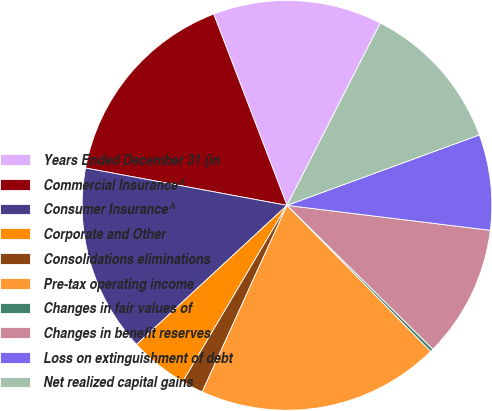Convert chart. <chart><loc_0><loc_0><loc_500><loc_500><pie_chart><fcel>Years Ended December 31 (in<fcel>Commercial Insurance^<fcel>Consumer Insurance^<fcel>Corporate and Other<fcel>Consolidations eliminations<fcel>Pre-tax operating income<fcel>Changes in fair values of<fcel>Changes in benefit reserves<fcel>Loss on extinguishment of debt<fcel>Net realized capital gains<nl><fcel>13.35%<fcel>16.26%<fcel>14.8%<fcel>4.62%<fcel>1.71%<fcel>19.16%<fcel>0.25%<fcel>10.44%<fcel>7.53%<fcel>11.89%<nl></chart> 